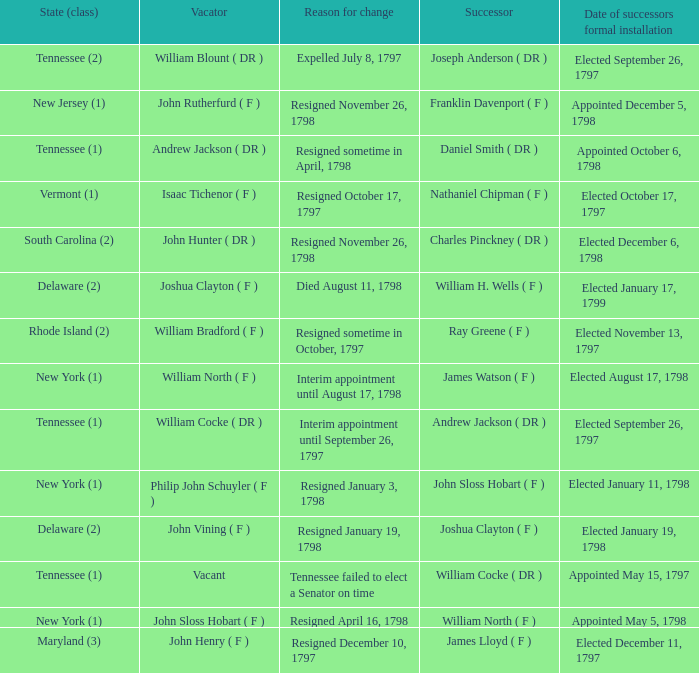What are all the states (class) when the successor was Joseph Anderson ( DR )? Tennessee (2). 